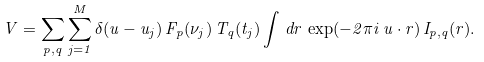<formula> <loc_0><loc_0><loc_500><loc_500>V = \sum _ { p , q } \sum _ { j = 1 } ^ { M } \delta ( u - u _ { j } ) \, F _ { p } ( \nu _ { j } ) \, T _ { q } ( t _ { j } ) \int \, d r \, \exp ( - 2 \pi i \, u \cdot r ) \, I _ { p , q } ( r ) .</formula> 